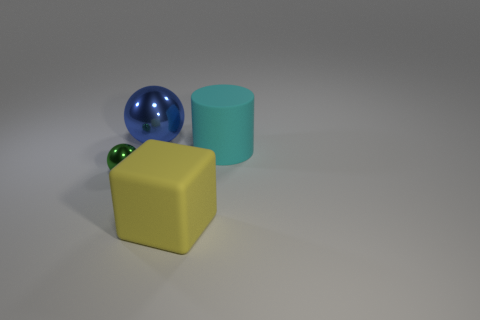How many things are right of the blue thing and in front of the cyan cylinder?
Offer a very short reply. 1. What is the color of the cube?
Your answer should be very brief. Yellow. Are there any large blue things that have the same material as the green sphere?
Make the answer very short. Yes. There is a big thing in front of the ball on the left side of the large blue sphere; are there any tiny green things on the right side of it?
Provide a succinct answer. No. There is a large blue object; are there any large blue balls in front of it?
Provide a succinct answer. No. Are there any other large cylinders of the same color as the big rubber cylinder?
Your answer should be very brief. No. How many large objects are rubber objects or green objects?
Your answer should be compact. 2. Is the material of the thing on the left side of the blue thing the same as the big yellow thing?
Your response must be concise. No. There is a metal thing that is behind the tiny green metallic sphere that is to the left of the rubber object in front of the tiny green metal object; what shape is it?
Offer a terse response. Sphere. How many cyan things are tiny things or large metal spheres?
Your answer should be very brief. 0. 